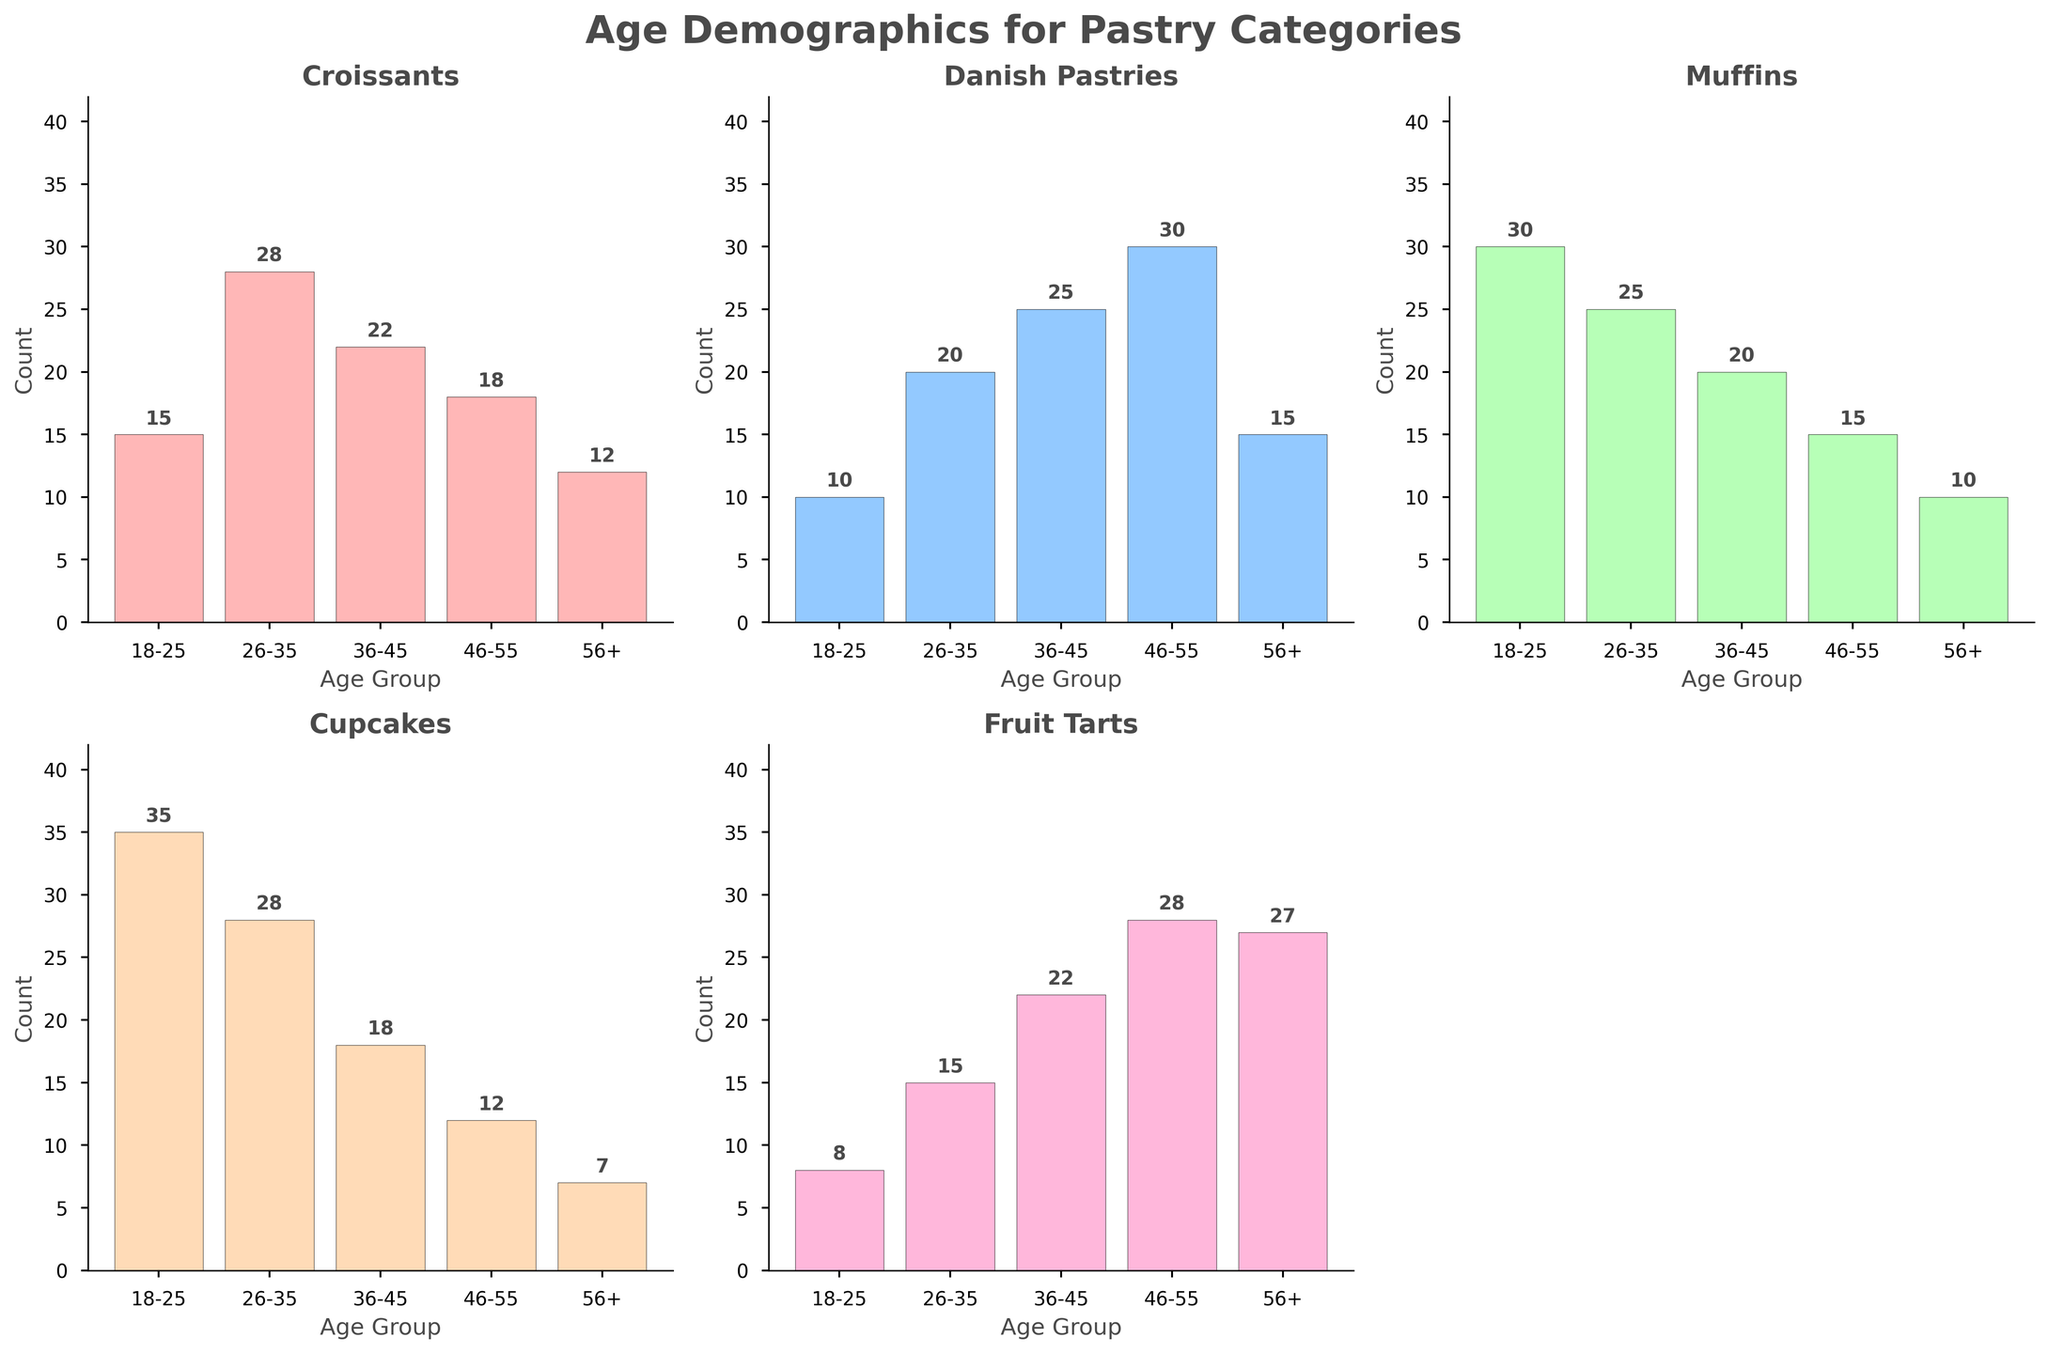What is the title of the figure? The title of the figure is located at the top. It reads "Age Demographics for Pastry Categories."
Answer: Age Demographics for Pastry Categories What age group has the highest count of customers for Cupcakes? By looking at the Cupcakes subplot, the bar corresponding to the 18-25 age group is the tallest.
Answer: 18-25 How many pastries are listed in the figure? There are multiple subplots, one for each pastry. Counting them, we find five categories: Croissants, Danish Pastries, Muffins, Cupcakes, and Fruit Tarts.
Answer: 5 Which pastry category has the highest count of customers in the 56+ age group? Review each subplot for the height of the 56+ age group bar. Fruit Tarts has the tallest bar for this age group.
Answer: Fruit Tarts What is the total count of customers for Croissants across all age groups? Adding up all the counts for Croissants: 15 (18-25) + 28 (26-35) + 22 (36-45) + 18 (46-55) + 12 (56+). 15 + 28 + 22 + 18 + 12 = 95
Answer: 95 For Muffins, which age group has the lowest count? In the Muffins subplot, the shortest bar is for the 56+ age group.
Answer: 56+ How does the age demographic for Danish Pastries compare to that of Fruit Tarts for the 46-55 age group? The bar for Danish Pastries (46-55) is shorter at a count of 30, whereas the count for Fruit Tarts (46-55) is higher with a count of 28. However, both are on the higher end for their respective pastries.
Answer: Danish Pastries: 30, Fruit Tarts: 28 